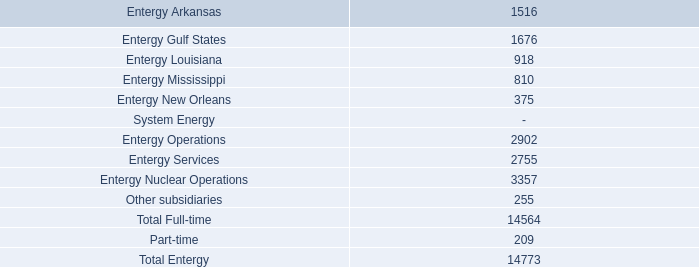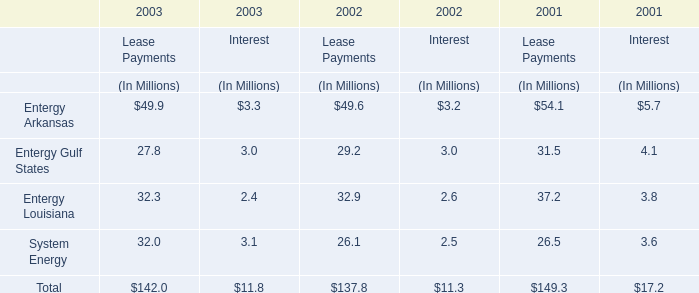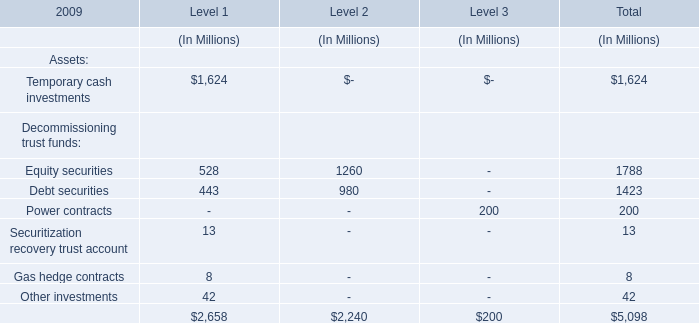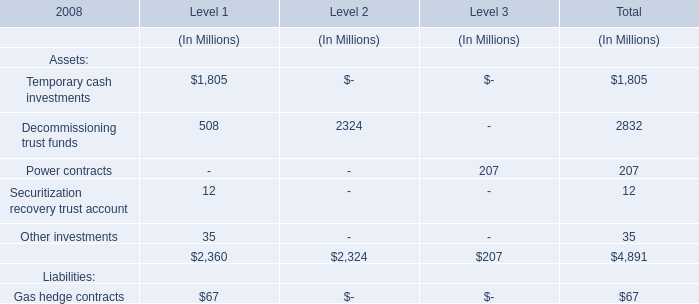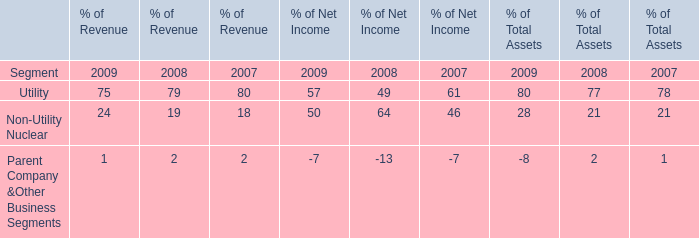What's the total amount of the Decommissioning trust funds in Table 3 in the years where Non-Utility Nuclear of Net Income in Table 4 is greater than 60? (in million) 
Computations: (508 + 2324)
Answer: 2832.0. 